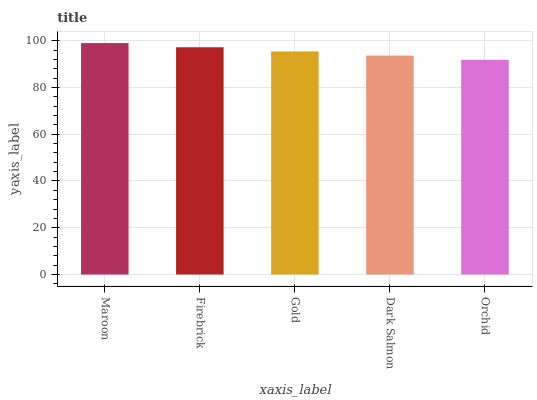Is Orchid the minimum?
Answer yes or no. Yes. Is Maroon the maximum?
Answer yes or no. Yes. Is Firebrick the minimum?
Answer yes or no. No. Is Firebrick the maximum?
Answer yes or no. No. Is Maroon greater than Firebrick?
Answer yes or no. Yes. Is Firebrick less than Maroon?
Answer yes or no. Yes. Is Firebrick greater than Maroon?
Answer yes or no. No. Is Maroon less than Firebrick?
Answer yes or no. No. Is Gold the high median?
Answer yes or no. Yes. Is Gold the low median?
Answer yes or no. Yes. Is Maroon the high median?
Answer yes or no. No. Is Orchid the low median?
Answer yes or no. No. 